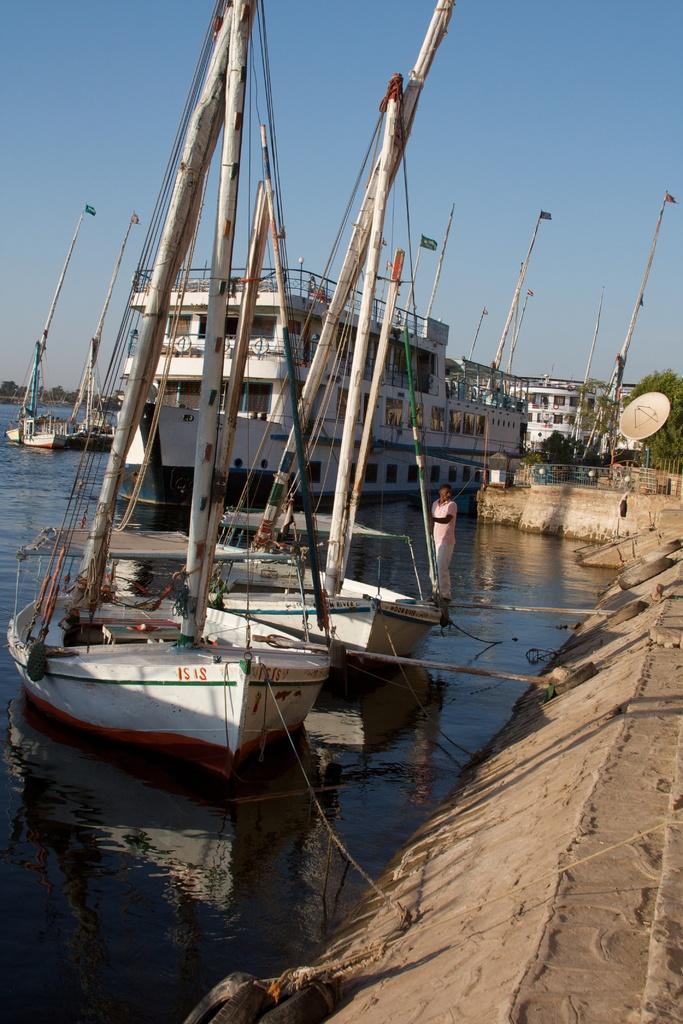Please provide a concise description of this image. In this image I can see few boats on the surface of the water, a ship which is white and green in color and few other boats on the surface of the water. I can see a person standing on the boat. In the background I can see few trees, few other ships and the sky. 